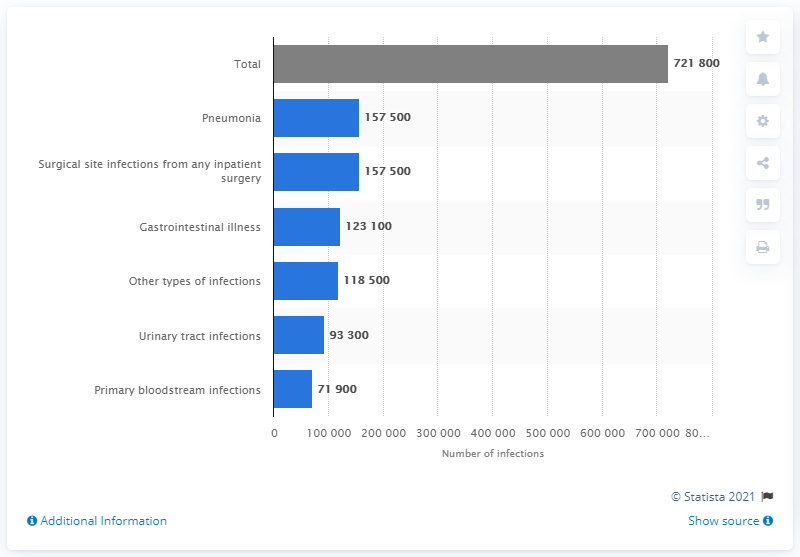Mention a couple of crucial points in this snapshot. In 2011, there were approximately 721,800 healthcare-associated infections (HAIs) that occurred in hospitals in the United States. 